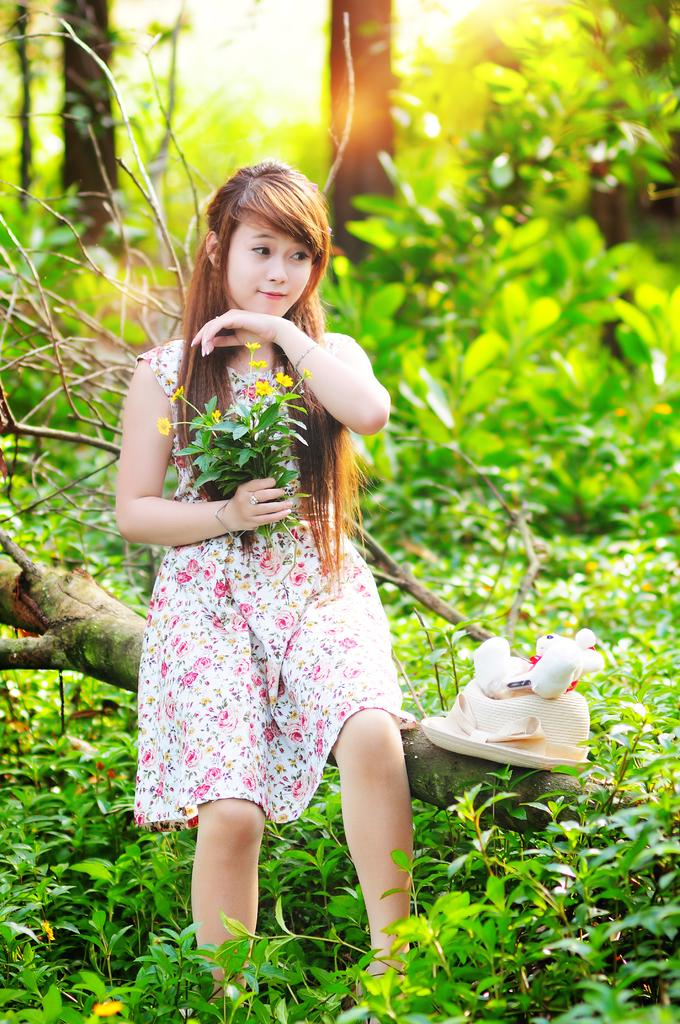Who is present in the image? There is a girl in the image. What is the girl doing in the image? The girl is sitting on a branch of a tree. What can be seen in the background of the image? There are trees and plants in the background of the image. What is the caption of the image? There is no caption present in the image. Can you describe the girl's teeth in the image? There is no information about the girl's teeth in the image, as it only shows her sitting on a tree branch. 